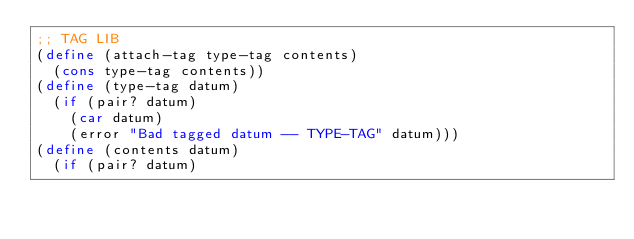Convert code to text. <code><loc_0><loc_0><loc_500><loc_500><_Scheme_>;; TAG LIB
(define (attach-tag type-tag contents)
  (cons type-tag contents))
(define (type-tag datum)
  (if (pair? datum)
    (car datum)
    (error "Bad tagged datum -- TYPE-TAG" datum)))
(define (contents datum)
  (if (pair? datum)</code> 